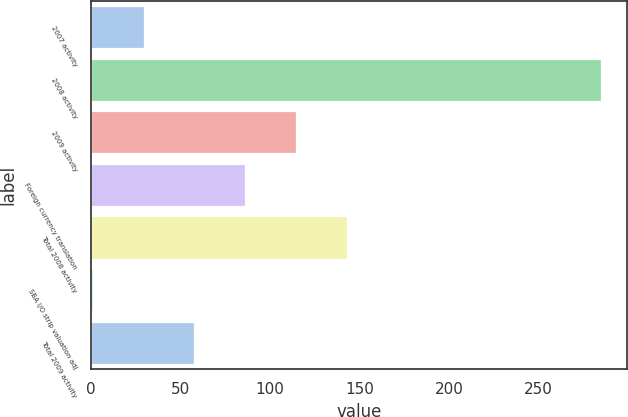Convert chart. <chart><loc_0><loc_0><loc_500><loc_500><bar_chart><fcel>2007 activity<fcel>2008 activity<fcel>2009 activity<fcel>Foreign currency translation<fcel>Total 2008 activity<fcel>SBA I/O strip valuation adj<fcel>Total 2009 activity<nl><fcel>29.4<fcel>285<fcel>114.6<fcel>86.2<fcel>143<fcel>1<fcel>57.8<nl></chart> 